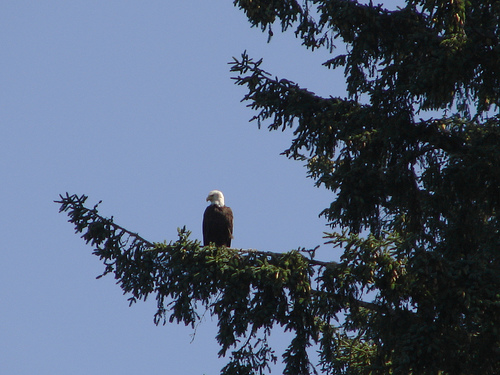<image>
Is there a eagle in the tree? No. The eagle is not contained within the tree. These objects have a different spatial relationship. 